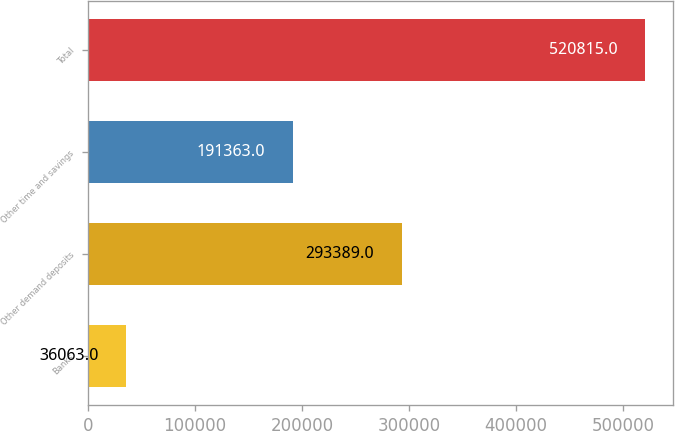Convert chart. <chart><loc_0><loc_0><loc_500><loc_500><bar_chart><fcel>Banks<fcel>Other demand deposits<fcel>Other time and savings<fcel>Total<nl><fcel>36063<fcel>293389<fcel>191363<fcel>520815<nl></chart> 